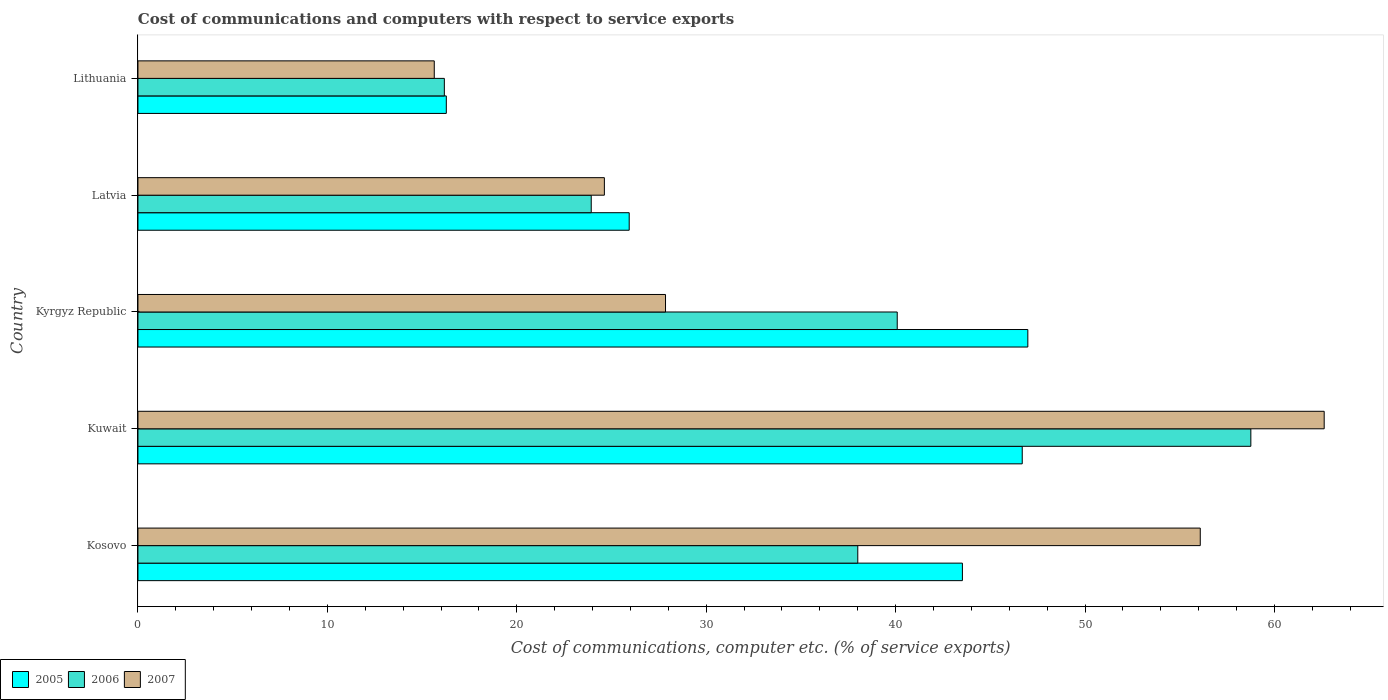Are the number of bars per tick equal to the number of legend labels?
Your answer should be very brief. Yes. How many bars are there on the 5th tick from the top?
Offer a very short reply. 3. What is the label of the 5th group of bars from the top?
Your answer should be very brief. Kosovo. In how many cases, is the number of bars for a given country not equal to the number of legend labels?
Your response must be concise. 0. What is the cost of communications and computers in 2007 in Kyrgyz Republic?
Give a very brief answer. 27.85. Across all countries, what is the maximum cost of communications and computers in 2006?
Your answer should be compact. 58.76. Across all countries, what is the minimum cost of communications and computers in 2006?
Your response must be concise. 16.18. In which country was the cost of communications and computers in 2007 maximum?
Offer a very short reply. Kuwait. In which country was the cost of communications and computers in 2006 minimum?
Your answer should be very brief. Lithuania. What is the total cost of communications and computers in 2007 in the graph?
Offer a very short reply. 186.83. What is the difference between the cost of communications and computers in 2006 in Kuwait and that in Latvia?
Offer a very short reply. 34.82. What is the difference between the cost of communications and computers in 2005 in Kosovo and the cost of communications and computers in 2006 in Latvia?
Your response must be concise. 19.6. What is the average cost of communications and computers in 2007 per country?
Give a very brief answer. 37.37. What is the difference between the cost of communications and computers in 2007 and cost of communications and computers in 2006 in Lithuania?
Offer a terse response. -0.53. In how many countries, is the cost of communications and computers in 2006 greater than 52 %?
Offer a very short reply. 1. What is the ratio of the cost of communications and computers in 2007 in Kosovo to that in Latvia?
Provide a short and direct response. 2.28. Is the cost of communications and computers in 2005 in Kosovo less than that in Kyrgyz Republic?
Offer a very short reply. Yes. Is the difference between the cost of communications and computers in 2007 in Kosovo and Kuwait greater than the difference between the cost of communications and computers in 2006 in Kosovo and Kuwait?
Offer a terse response. Yes. What is the difference between the highest and the second highest cost of communications and computers in 2007?
Offer a terse response. 6.54. What is the difference between the highest and the lowest cost of communications and computers in 2006?
Provide a succinct answer. 42.58. Is the sum of the cost of communications and computers in 2007 in Kosovo and Lithuania greater than the maximum cost of communications and computers in 2005 across all countries?
Your answer should be very brief. Yes. How many bars are there?
Offer a terse response. 15. How many countries are there in the graph?
Your answer should be compact. 5. What is the difference between two consecutive major ticks on the X-axis?
Your answer should be very brief. 10. Does the graph contain any zero values?
Make the answer very short. No. What is the title of the graph?
Provide a short and direct response. Cost of communications and computers with respect to service exports. What is the label or title of the X-axis?
Provide a succinct answer. Cost of communications, computer etc. (% of service exports). What is the Cost of communications, computer etc. (% of service exports) of 2005 in Kosovo?
Provide a succinct answer. 43.53. What is the Cost of communications, computer etc. (% of service exports) in 2006 in Kosovo?
Offer a terse response. 38. What is the Cost of communications, computer etc. (% of service exports) in 2007 in Kosovo?
Keep it short and to the point. 56.09. What is the Cost of communications, computer etc. (% of service exports) of 2005 in Kuwait?
Ensure brevity in your answer.  46.69. What is the Cost of communications, computer etc. (% of service exports) in 2006 in Kuwait?
Offer a very short reply. 58.76. What is the Cost of communications, computer etc. (% of service exports) in 2007 in Kuwait?
Your answer should be very brief. 62.63. What is the Cost of communications, computer etc. (% of service exports) in 2005 in Kyrgyz Republic?
Your answer should be very brief. 46.98. What is the Cost of communications, computer etc. (% of service exports) of 2006 in Kyrgyz Republic?
Ensure brevity in your answer.  40.09. What is the Cost of communications, computer etc. (% of service exports) in 2007 in Kyrgyz Republic?
Your response must be concise. 27.85. What is the Cost of communications, computer etc. (% of service exports) in 2005 in Latvia?
Provide a succinct answer. 25.94. What is the Cost of communications, computer etc. (% of service exports) in 2006 in Latvia?
Your answer should be very brief. 23.93. What is the Cost of communications, computer etc. (% of service exports) of 2007 in Latvia?
Provide a succinct answer. 24.62. What is the Cost of communications, computer etc. (% of service exports) of 2005 in Lithuania?
Provide a succinct answer. 16.28. What is the Cost of communications, computer etc. (% of service exports) of 2006 in Lithuania?
Give a very brief answer. 16.18. What is the Cost of communications, computer etc. (% of service exports) of 2007 in Lithuania?
Offer a very short reply. 15.64. Across all countries, what is the maximum Cost of communications, computer etc. (% of service exports) of 2005?
Keep it short and to the point. 46.98. Across all countries, what is the maximum Cost of communications, computer etc. (% of service exports) in 2006?
Make the answer very short. 58.76. Across all countries, what is the maximum Cost of communications, computer etc. (% of service exports) of 2007?
Provide a short and direct response. 62.63. Across all countries, what is the minimum Cost of communications, computer etc. (% of service exports) of 2005?
Offer a very short reply. 16.28. Across all countries, what is the minimum Cost of communications, computer etc. (% of service exports) of 2006?
Your response must be concise. 16.18. Across all countries, what is the minimum Cost of communications, computer etc. (% of service exports) of 2007?
Give a very brief answer. 15.64. What is the total Cost of communications, computer etc. (% of service exports) in 2005 in the graph?
Give a very brief answer. 179.41. What is the total Cost of communications, computer etc. (% of service exports) in 2006 in the graph?
Your response must be concise. 176.95. What is the total Cost of communications, computer etc. (% of service exports) of 2007 in the graph?
Keep it short and to the point. 186.83. What is the difference between the Cost of communications, computer etc. (% of service exports) of 2005 in Kosovo and that in Kuwait?
Provide a short and direct response. -3.16. What is the difference between the Cost of communications, computer etc. (% of service exports) in 2006 in Kosovo and that in Kuwait?
Give a very brief answer. -20.75. What is the difference between the Cost of communications, computer etc. (% of service exports) in 2007 in Kosovo and that in Kuwait?
Offer a terse response. -6.54. What is the difference between the Cost of communications, computer etc. (% of service exports) in 2005 in Kosovo and that in Kyrgyz Republic?
Ensure brevity in your answer.  -3.45. What is the difference between the Cost of communications, computer etc. (% of service exports) in 2006 in Kosovo and that in Kyrgyz Republic?
Provide a succinct answer. -2.08. What is the difference between the Cost of communications, computer etc. (% of service exports) in 2007 in Kosovo and that in Kyrgyz Republic?
Provide a short and direct response. 28.23. What is the difference between the Cost of communications, computer etc. (% of service exports) of 2005 in Kosovo and that in Latvia?
Offer a very short reply. 17.59. What is the difference between the Cost of communications, computer etc. (% of service exports) in 2006 in Kosovo and that in Latvia?
Give a very brief answer. 14.07. What is the difference between the Cost of communications, computer etc. (% of service exports) in 2007 in Kosovo and that in Latvia?
Provide a short and direct response. 31.46. What is the difference between the Cost of communications, computer etc. (% of service exports) in 2005 in Kosovo and that in Lithuania?
Offer a terse response. 27.25. What is the difference between the Cost of communications, computer etc. (% of service exports) of 2006 in Kosovo and that in Lithuania?
Provide a succinct answer. 21.83. What is the difference between the Cost of communications, computer etc. (% of service exports) in 2007 in Kosovo and that in Lithuania?
Make the answer very short. 40.44. What is the difference between the Cost of communications, computer etc. (% of service exports) of 2005 in Kuwait and that in Kyrgyz Republic?
Your answer should be compact. -0.3. What is the difference between the Cost of communications, computer etc. (% of service exports) of 2006 in Kuwait and that in Kyrgyz Republic?
Provide a succinct answer. 18.67. What is the difference between the Cost of communications, computer etc. (% of service exports) in 2007 in Kuwait and that in Kyrgyz Republic?
Your answer should be compact. 34.77. What is the difference between the Cost of communications, computer etc. (% of service exports) of 2005 in Kuwait and that in Latvia?
Give a very brief answer. 20.75. What is the difference between the Cost of communications, computer etc. (% of service exports) in 2006 in Kuwait and that in Latvia?
Offer a very short reply. 34.82. What is the difference between the Cost of communications, computer etc. (% of service exports) in 2007 in Kuwait and that in Latvia?
Make the answer very short. 38. What is the difference between the Cost of communications, computer etc. (% of service exports) in 2005 in Kuwait and that in Lithuania?
Keep it short and to the point. 30.41. What is the difference between the Cost of communications, computer etc. (% of service exports) of 2006 in Kuwait and that in Lithuania?
Ensure brevity in your answer.  42.58. What is the difference between the Cost of communications, computer etc. (% of service exports) of 2007 in Kuwait and that in Lithuania?
Give a very brief answer. 46.98. What is the difference between the Cost of communications, computer etc. (% of service exports) of 2005 in Kyrgyz Republic and that in Latvia?
Make the answer very short. 21.05. What is the difference between the Cost of communications, computer etc. (% of service exports) in 2006 in Kyrgyz Republic and that in Latvia?
Give a very brief answer. 16.16. What is the difference between the Cost of communications, computer etc. (% of service exports) of 2007 in Kyrgyz Republic and that in Latvia?
Keep it short and to the point. 3.23. What is the difference between the Cost of communications, computer etc. (% of service exports) of 2005 in Kyrgyz Republic and that in Lithuania?
Provide a succinct answer. 30.7. What is the difference between the Cost of communications, computer etc. (% of service exports) in 2006 in Kyrgyz Republic and that in Lithuania?
Your response must be concise. 23.91. What is the difference between the Cost of communications, computer etc. (% of service exports) of 2007 in Kyrgyz Republic and that in Lithuania?
Keep it short and to the point. 12.21. What is the difference between the Cost of communications, computer etc. (% of service exports) in 2005 in Latvia and that in Lithuania?
Ensure brevity in your answer.  9.66. What is the difference between the Cost of communications, computer etc. (% of service exports) of 2006 in Latvia and that in Lithuania?
Offer a very short reply. 7.76. What is the difference between the Cost of communications, computer etc. (% of service exports) in 2007 in Latvia and that in Lithuania?
Offer a terse response. 8.98. What is the difference between the Cost of communications, computer etc. (% of service exports) of 2005 in Kosovo and the Cost of communications, computer etc. (% of service exports) of 2006 in Kuwait?
Provide a succinct answer. -15.23. What is the difference between the Cost of communications, computer etc. (% of service exports) in 2005 in Kosovo and the Cost of communications, computer etc. (% of service exports) in 2007 in Kuwait?
Ensure brevity in your answer.  -19.1. What is the difference between the Cost of communications, computer etc. (% of service exports) of 2006 in Kosovo and the Cost of communications, computer etc. (% of service exports) of 2007 in Kuwait?
Your answer should be compact. -24.62. What is the difference between the Cost of communications, computer etc. (% of service exports) in 2005 in Kosovo and the Cost of communications, computer etc. (% of service exports) in 2006 in Kyrgyz Republic?
Your answer should be very brief. 3.44. What is the difference between the Cost of communications, computer etc. (% of service exports) of 2005 in Kosovo and the Cost of communications, computer etc. (% of service exports) of 2007 in Kyrgyz Republic?
Offer a terse response. 15.67. What is the difference between the Cost of communications, computer etc. (% of service exports) in 2006 in Kosovo and the Cost of communications, computer etc. (% of service exports) in 2007 in Kyrgyz Republic?
Keep it short and to the point. 10.15. What is the difference between the Cost of communications, computer etc. (% of service exports) in 2005 in Kosovo and the Cost of communications, computer etc. (% of service exports) in 2006 in Latvia?
Offer a terse response. 19.6. What is the difference between the Cost of communications, computer etc. (% of service exports) in 2005 in Kosovo and the Cost of communications, computer etc. (% of service exports) in 2007 in Latvia?
Offer a terse response. 18.9. What is the difference between the Cost of communications, computer etc. (% of service exports) in 2006 in Kosovo and the Cost of communications, computer etc. (% of service exports) in 2007 in Latvia?
Your response must be concise. 13.38. What is the difference between the Cost of communications, computer etc. (% of service exports) of 2005 in Kosovo and the Cost of communications, computer etc. (% of service exports) of 2006 in Lithuania?
Your response must be concise. 27.35. What is the difference between the Cost of communications, computer etc. (% of service exports) in 2005 in Kosovo and the Cost of communications, computer etc. (% of service exports) in 2007 in Lithuania?
Offer a very short reply. 27.88. What is the difference between the Cost of communications, computer etc. (% of service exports) in 2006 in Kosovo and the Cost of communications, computer etc. (% of service exports) in 2007 in Lithuania?
Offer a terse response. 22.36. What is the difference between the Cost of communications, computer etc. (% of service exports) in 2005 in Kuwait and the Cost of communications, computer etc. (% of service exports) in 2006 in Kyrgyz Republic?
Provide a short and direct response. 6.6. What is the difference between the Cost of communications, computer etc. (% of service exports) in 2005 in Kuwait and the Cost of communications, computer etc. (% of service exports) in 2007 in Kyrgyz Republic?
Provide a succinct answer. 18.83. What is the difference between the Cost of communications, computer etc. (% of service exports) of 2006 in Kuwait and the Cost of communications, computer etc. (% of service exports) of 2007 in Kyrgyz Republic?
Offer a very short reply. 30.9. What is the difference between the Cost of communications, computer etc. (% of service exports) of 2005 in Kuwait and the Cost of communications, computer etc. (% of service exports) of 2006 in Latvia?
Offer a very short reply. 22.75. What is the difference between the Cost of communications, computer etc. (% of service exports) in 2005 in Kuwait and the Cost of communications, computer etc. (% of service exports) in 2007 in Latvia?
Offer a very short reply. 22.06. What is the difference between the Cost of communications, computer etc. (% of service exports) of 2006 in Kuwait and the Cost of communications, computer etc. (% of service exports) of 2007 in Latvia?
Provide a succinct answer. 34.13. What is the difference between the Cost of communications, computer etc. (% of service exports) of 2005 in Kuwait and the Cost of communications, computer etc. (% of service exports) of 2006 in Lithuania?
Offer a very short reply. 30.51. What is the difference between the Cost of communications, computer etc. (% of service exports) of 2005 in Kuwait and the Cost of communications, computer etc. (% of service exports) of 2007 in Lithuania?
Give a very brief answer. 31.04. What is the difference between the Cost of communications, computer etc. (% of service exports) in 2006 in Kuwait and the Cost of communications, computer etc. (% of service exports) in 2007 in Lithuania?
Keep it short and to the point. 43.11. What is the difference between the Cost of communications, computer etc. (% of service exports) in 2005 in Kyrgyz Republic and the Cost of communications, computer etc. (% of service exports) in 2006 in Latvia?
Ensure brevity in your answer.  23.05. What is the difference between the Cost of communications, computer etc. (% of service exports) in 2005 in Kyrgyz Republic and the Cost of communications, computer etc. (% of service exports) in 2007 in Latvia?
Provide a short and direct response. 22.36. What is the difference between the Cost of communications, computer etc. (% of service exports) in 2006 in Kyrgyz Republic and the Cost of communications, computer etc. (% of service exports) in 2007 in Latvia?
Provide a short and direct response. 15.46. What is the difference between the Cost of communications, computer etc. (% of service exports) in 2005 in Kyrgyz Republic and the Cost of communications, computer etc. (% of service exports) in 2006 in Lithuania?
Keep it short and to the point. 30.81. What is the difference between the Cost of communications, computer etc. (% of service exports) in 2005 in Kyrgyz Republic and the Cost of communications, computer etc. (% of service exports) in 2007 in Lithuania?
Your answer should be compact. 31.34. What is the difference between the Cost of communications, computer etc. (% of service exports) in 2006 in Kyrgyz Republic and the Cost of communications, computer etc. (% of service exports) in 2007 in Lithuania?
Keep it short and to the point. 24.44. What is the difference between the Cost of communications, computer etc. (% of service exports) of 2005 in Latvia and the Cost of communications, computer etc. (% of service exports) of 2006 in Lithuania?
Provide a short and direct response. 9.76. What is the difference between the Cost of communications, computer etc. (% of service exports) of 2005 in Latvia and the Cost of communications, computer etc. (% of service exports) of 2007 in Lithuania?
Give a very brief answer. 10.29. What is the difference between the Cost of communications, computer etc. (% of service exports) of 2006 in Latvia and the Cost of communications, computer etc. (% of service exports) of 2007 in Lithuania?
Provide a succinct answer. 8.29. What is the average Cost of communications, computer etc. (% of service exports) in 2005 per country?
Give a very brief answer. 35.88. What is the average Cost of communications, computer etc. (% of service exports) of 2006 per country?
Offer a terse response. 35.39. What is the average Cost of communications, computer etc. (% of service exports) of 2007 per country?
Offer a very short reply. 37.37. What is the difference between the Cost of communications, computer etc. (% of service exports) in 2005 and Cost of communications, computer etc. (% of service exports) in 2006 in Kosovo?
Offer a terse response. 5.52. What is the difference between the Cost of communications, computer etc. (% of service exports) in 2005 and Cost of communications, computer etc. (% of service exports) in 2007 in Kosovo?
Your answer should be very brief. -12.56. What is the difference between the Cost of communications, computer etc. (% of service exports) of 2006 and Cost of communications, computer etc. (% of service exports) of 2007 in Kosovo?
Offer a terse response. -18.08. What is the difference between the Cost of communications, computer etc. (% of service exports) of 2005 and Cost of communications, computer etc. (% of service exports) of 2006 in Kuwait?
Your response must be concise. -12.07. What is the difference between the Cost of communications, computer etc. (% of service exports) in 2005 and Cost of communications, computer etc. (% of service exports) in 2007 in Kuwait?
Offer a terse response. -15.94. What is the difference between the Cost of communications, computer etc. (% of service exports) in 2006 and Cost of communications, computer etc. (% of service exports) in 2007 in Kuwait?
Ensure brevity in your answer.  -3.87. What is the difference between the Cost of communications, computer etc. (% of service exports) of 2005 and Cost of communications, computer etc. (% of service exports) of 2006 in Kyrgyz Republic?
Your response must be concise. 6.89. What is the difference between the Cost of communications, computer etc. (% of service exports) in 2005 and Cost of communications, computer etc. (% of service exports) in 2007 in Kyrgyz Republic?
Keep it short and to the point. 19.13. What is the difference between the Cost of communications, computer etc. (% of service exports) of 2006 and Cost of communications, computer etc. (% of service exports) of 2007 in Kyrgyz Republic?
Ensure brevity in your answer.  12.23. What is the difference between the Cost of communications, computer etc. (% of service exports) of 2005 and Cost of communications, computer etc. (% of service exports) of 2006 in Latvia?
Give a very brief answer. 2. What is the difference between the Cost of communications, computer etc. (% of service exports) of 2005 and Cost of communications, computer etc. (% of service exports) of 2007 in Latvia?
Provide a short and direct response. 1.31. What is the difference between the Cost of communications, computer etc. (% of service exports) of 2006 and Cost of communications, computer etc. (% of service exports) of 2007 in Latvia?
Make the answer very short. -0.69. What is the difference between the Cost of communications, computer etc. (% of service exports) in 2005 and Cost of communications, computer etc. (% of service exports) in 2006 in Lithuania?
Give a very brief answer. 0.1. What is the difference between the Cost of communications, computer etc. (% of service exports) in 2005 and Cost of communications, computer etc. (% of service exports) in 2007 in Lithuania?
Offer a very short reply. 0.64. What is the difference between the Cost of communications, computer etc. (% of service exports) of 2006 and Cost of communications, computer etc. (% of service exports) of 2007 in Lithuania?
Keep it short and to the point. 0.53. What is the ratio of the Cost of communications, computer etc. (% of service exports) in 2005 in Kosovo to that in Kuwait?
Keep it short and to the point. 0.93. What is the ratio of the Cost of communications, computer etc. (% of service exports) in 2006 in Kosovo to that in Kuwait?
Your answer should be very brief. 0.65. What is the ratio of the Cost of communications, computer etc. (% of service exports) of 2007 in Kosovo to that in Kuwait?
Your response must be concise. 0.9. What is the ratio of the Cost of communications, computer etc. (% of service exports) in 2005 in Kosovo to that in Kyrgyz Republic?
Your answer should be very brief. 0.93. What is the ratio of the Cost of communications, computer etc. (% of service exports) in 2006 in Kosovo to that in Kyrgyz Republic?
Ensure brevity in your answer.  0.95. What is the ratio of the Cost of communications, computer etc. (% of service exports) in 2007 in Kosovo to that in Kyrgyz Republic?
Your response must be concise. 2.01. What is the ratio of the Cost of communications, computer etc. (% of service exports) of 2005 in Kosovo to that in Latvia?
Provide a short and direct response. 1.68. What is the ratio of the Cost of communications, computer etc. (% of service exports) in 2006 in Kosovo to that in Latvia?
Offer a very short reply. 1.59. What is the ratio of the Cost of communications, computer etc. (% of service exports) in 2007 in Kosovo to that in Latvia?
Your answer should be compact. 2.28. What is the ratio of the Cost of communications, computer etc. (% of service exports) of 2005 in Kosovo to that in Lithuania?
Keep it short and to the point. 2.67. What is the ratio of the Cost of communications, computer etc. (% of service exports) of 2006 in Kosovo to that in Lithuania?
Offer a very short reply. 2.35. What is the ratio of the Cost of communications, computer etc. (% of service exports) in 2007 in Kosovo to that in Lithuania?
Your response must be concise. 3.59. What is the ratio of the Cost of communications, computer etc. (% of service exports) of 2005 in Kuwait to that in Kyrgyz Republic?
Your response must be concise. 0.99. What is the ratio of the Cost of communications, computer etc. (% of service exports) in 2006 in Kuwait to that in Kyrgyz Republic?
Your answer should be compact. 1.47. What is the ratio of the Cost of communications, computer etc. (% of service exports) of 2007 in Kuwait to that in Kyrgyz Republic?
Your response must be concise. 2.25. What is the ratio of the Cost of communications, computer etc. (% of service exports) of 2005 in Kuwait to that in Latvia?
Give a very brief answer. 1.8. What is the ratio of the Cost of communications, computer etc. (% of service exports) in 2006 in Kuwait to that in Latvia?
Make the answer very short. 2.46. What is the ratio of the Cost of communications, computer etc. (% of service exports) of 2007 in Kuwait to that in Latvia?
Ensure brevity in your answer.  2.54. What is the ratio of the Cost of communications, computer etc. (% of service exports) in 2005 in Kuwait to that in Lithuania?
Give a very brief answer. 2.87. What is the ratio of the Cost of communications, computer etc. (% of service exports) of 2006 in Kuwait to that in Lithuania?
Keep it short and to the point. 3.63. What is the ratio of the Cost of communications, computer etc. (% of service exports) of 2007 in Kuwait to that in Lithuania?
Your answer should be very brief. 4. What is the ratio of the Cost of communications, computer etc. (% of service exports) in 2005 in Kyrgyz Republic to that in Latvia?
Offer a very short reply. 1.81. What is the ratio of the Cost of communications, computer etc. (% of service exports) of 2006 in Kyrgyz Republic to that in Latvia?
Provide a succinct answer. 1.68. What is the ratio of the Cost of communications, computer etc. (% of service exports) in 2007 in Kyrgyz Republic to that in Latvia?
Give a very brief answer. 1.13. What is the ratio of the Cost of communications, computer etc. (% of service exports) in 2005 in Kyrgyz Republic to that in Lithuania?
Ensure brevity in your answer.  2.89. What is the ratio of the Cost of communications, computer etc. (% of service exports) of 2006 in Kyrgyz Republic to that in Lithuania?
Ensure brevity in your answer.  2.48. What is the ratio of the Cost of communications, computer etc. (% of service exports) in 2007 in Kyrgyz Republic to that in Lithuania?
Keep it short and to the point. 1.78. What is the ratio of the Cost of communications, computer etc. (% of service exports) of 2005 in Latvia to that in Lithuania?
Your answer should be very brief. 1.59. What is the ratio of the Cost of communications, computer etc. (% of service exports) in 2006 in Latvia to that in Lithuania?
Make the answer very short. 1.48. What is the ratio of the Cost of communications, computer etc. (% of service exports) of 2007 in Latvia to that in Lithuania?
Your response must be concise. 1.57. What is the difference between the highest and the second highest Cost of communications, computer etc. (% of service exports) in 2005?
Give a very brief answer. 0.3. What is the difference between the highest and the second highest Cost of communications, computer etc. (% of service exports) of 2006?
Provide a short and direct response. 18.67. What is the difference between the highest and the second highest Cost of communications, computer etc. (% of service exports) in 2007?
Your response must be concise. 6.54. What is the difference between the highest and the lowest Cost of communications, computer etc. (% of service exports) of 2005?
Provide a short and direct response. 30.7. What is the difference between the highest and the lowest Cost of communications, computer etc. (% of service exports) in 2006?
Your response must be concise. 42.58. What is the difference between the highest and the lowest Cost of communications, computer etc. (% of service exports) in 2007?
Ensure brevity in your answer.  46.98. 